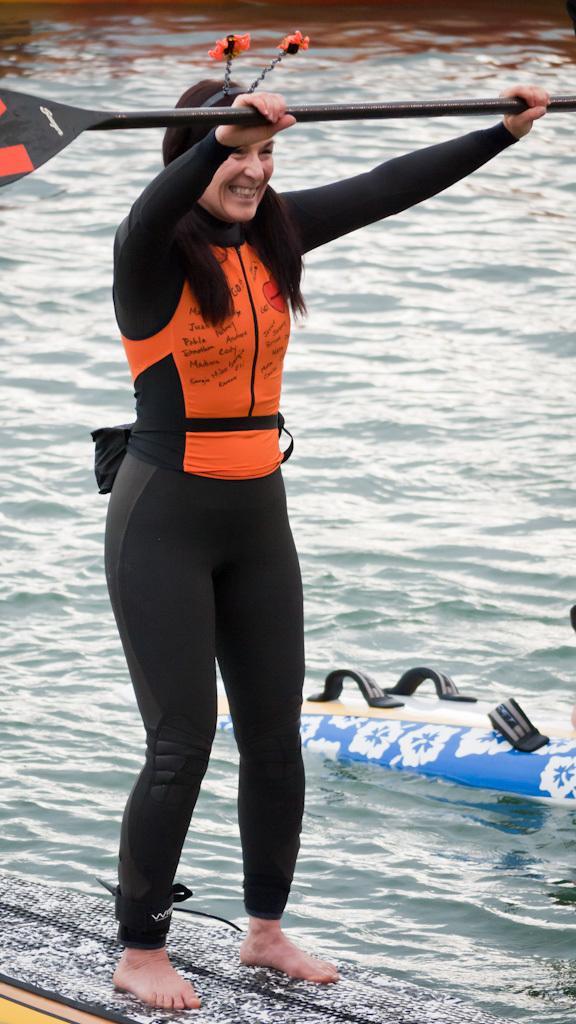Describe this image in one or two sentences. In this picture I can see a woman holding a pedal in her hands and standing on the surfboard and I can see water and another surf board on the right side. 